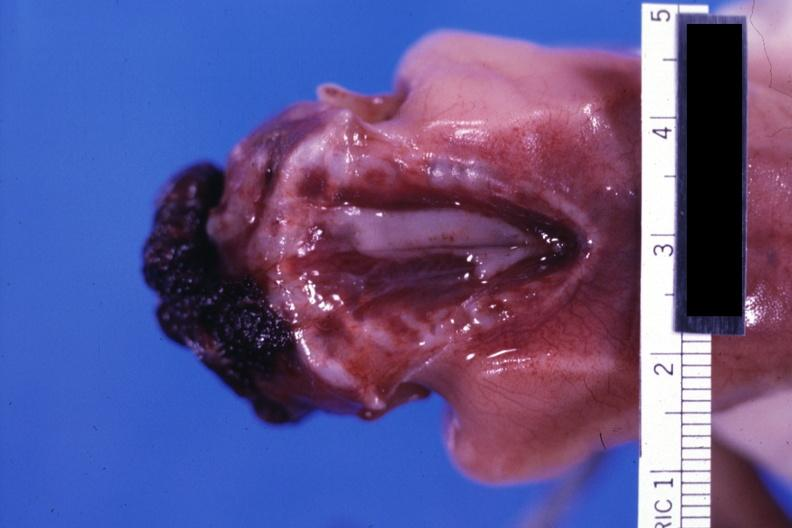what is present?
Answer the question using a single word or phrase. Anencephaly 